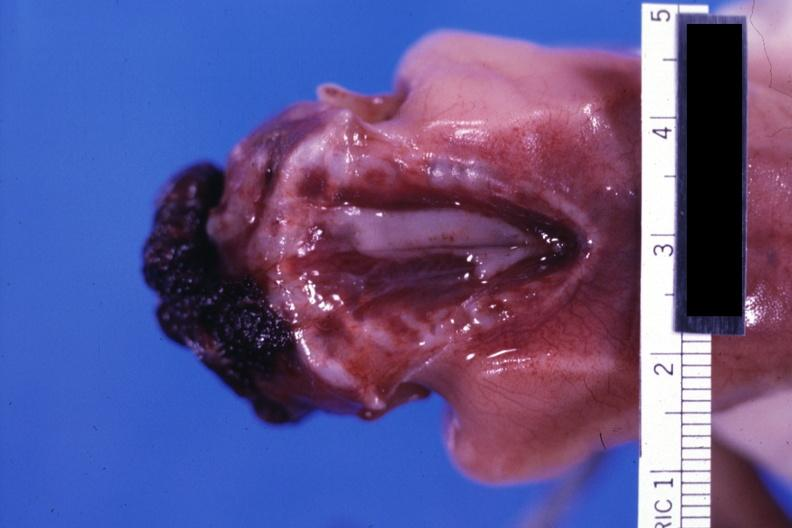what is present?
Answer the question using a single word or phrase. Anencephaly 